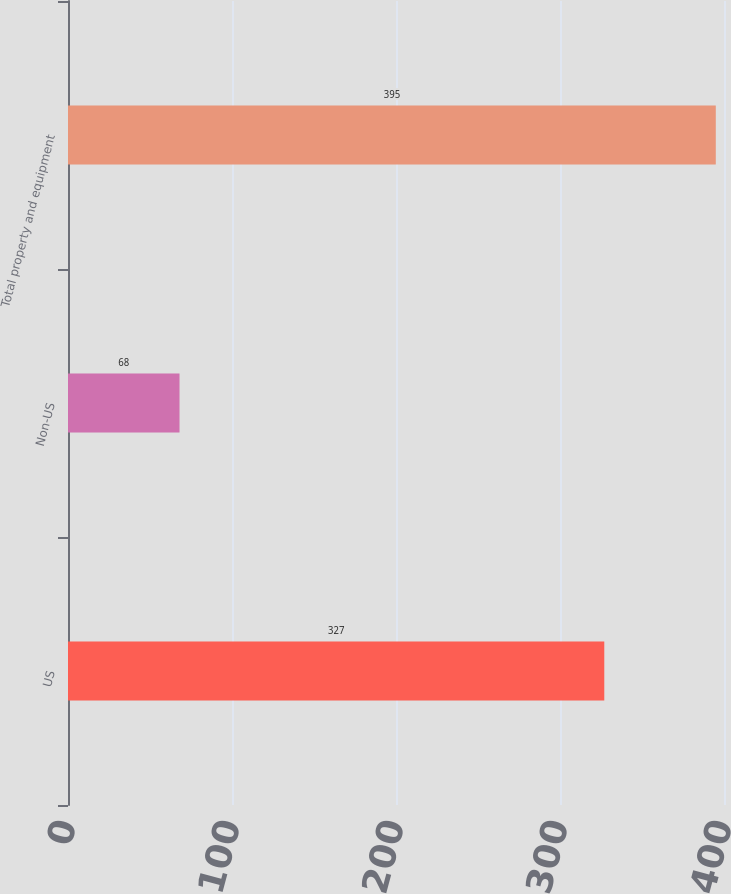<chart> <loc_0><loc_0><loc_500><loc_500><bar_chart><fcel>US<fcel>Non-US<fcel>Total property and equipment<nl><fcel>327<fcel>68<fcel>395<nl></chart> 